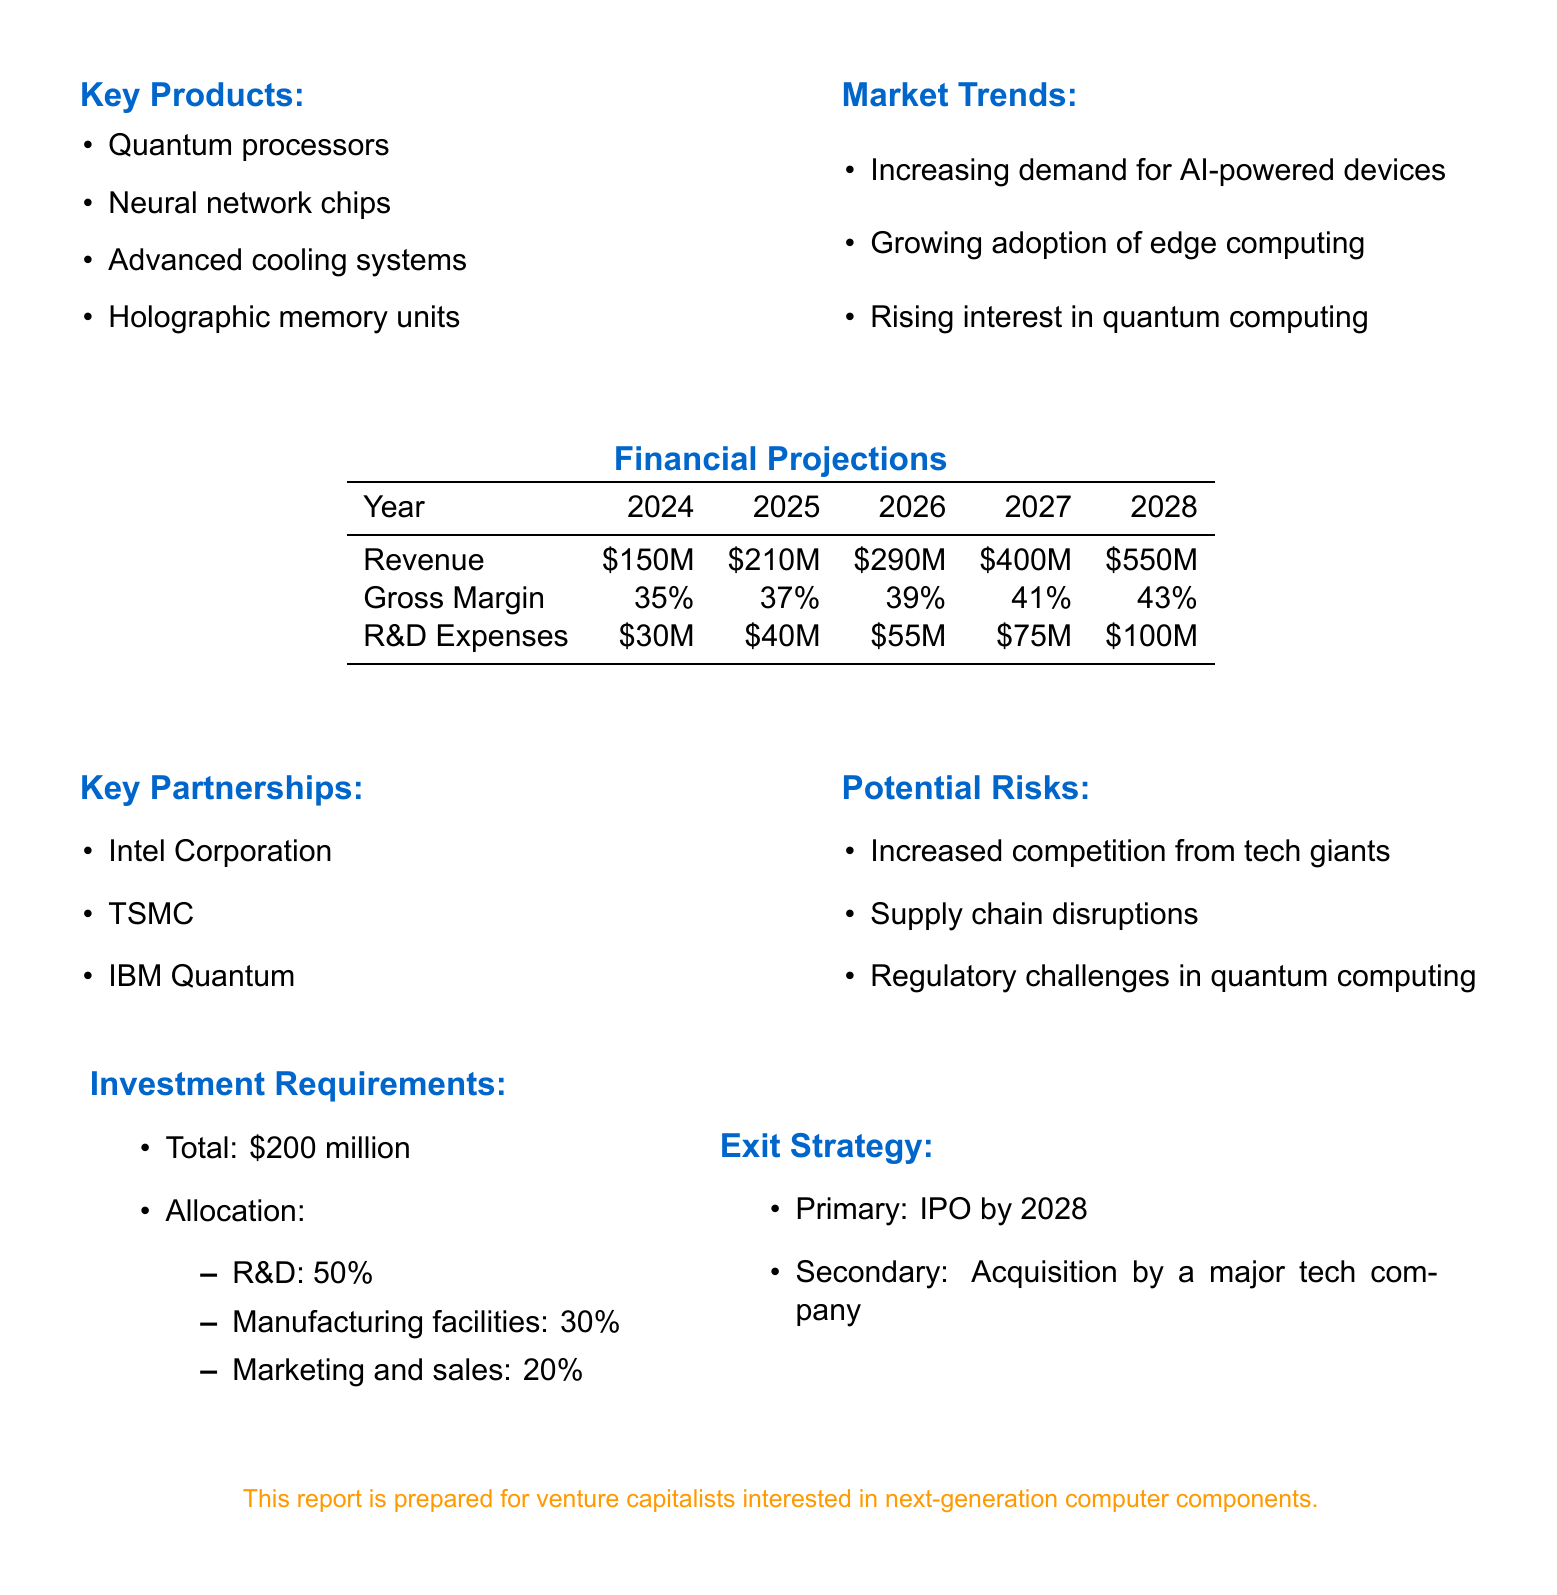What is the company name? The company name is stated at the beginning of the document, identified as NexTech Components Ltd.
Answer: NexTech Components Ltd What are the key products? The document lists four key products produced by the company, which are specified in a bullet-point format.
Answer: Quantum processors, Neural network chips, Advanced cooling systems, Holographic memory units What is the projected revenue for 2026? The projected revenue for 2026 is included in the financial projections table, indicating the expected income for that year.
Answer: $290 million What percentage of the total investment is allocated to R&D? The allocation section under investment requirements specifies the percentage allocated to R&D, detailing the investment breakdown clearly.
Answer: 50% What is the exit strategy? The exit strategy is outlined at the end of the document, offering the primary and secondary options for investors.
Answer: IPO by 2028 Which key partnership involves quantum technology? The document specifically mentions key partnerships, including one focused on quantum technology, highlighting collaboration with another company.
Answer: IBM Quantum What is the gross margin projected for 2027? The gross margin for each year is detailed in the financial projections table, allowing for retrieval of specific percentages for the respective years.
Answer: 41% What potential risk includes supply chain issues? The potential risks listed in the document each identify threats to the company's stability, with one specifically relating to the supply chain.
Answer: Supply chain disruptions What is the total investment requirement? The investment requirements section explicitly states the total amount needed for the company's initiatives, providing clear financial expectations.
Answer: $200 million 